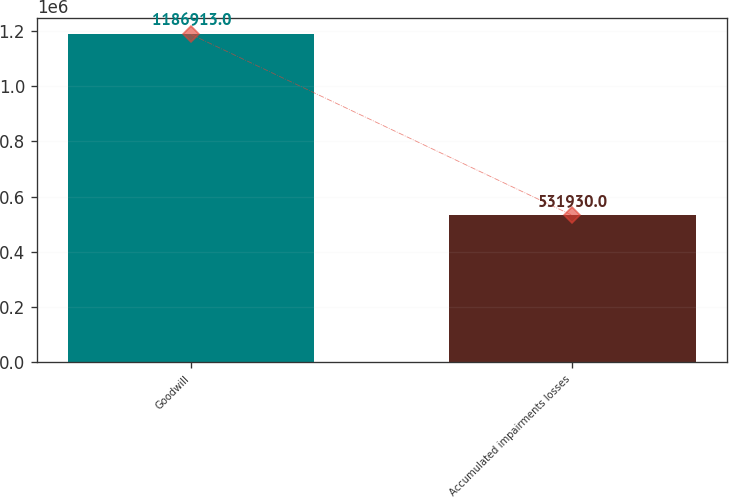Convert chart to OTSL. <chart><loc_0><loc_0><loc_500><loc_500><bar_chart><fcel>Goodwill<fcel>Accumulated impairments losses<nl><fcel>1.18691e+06<fcel>531930<nl></chart> 